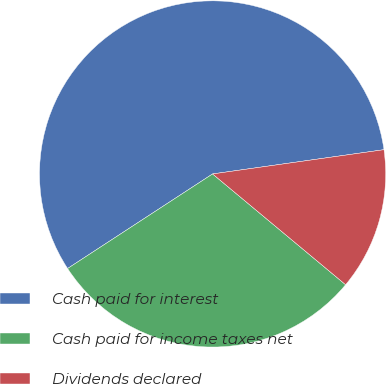<chart> <loc_0><loc_0><loc_500><loc_500><pie_chart><fcel>Cash paid for interest<fcel>Cash paid for income taxes net<fcel>Dividends declared<nl><fcel>56.96%<fcel>29.75%<fcel>13.29%<nl></chart> 